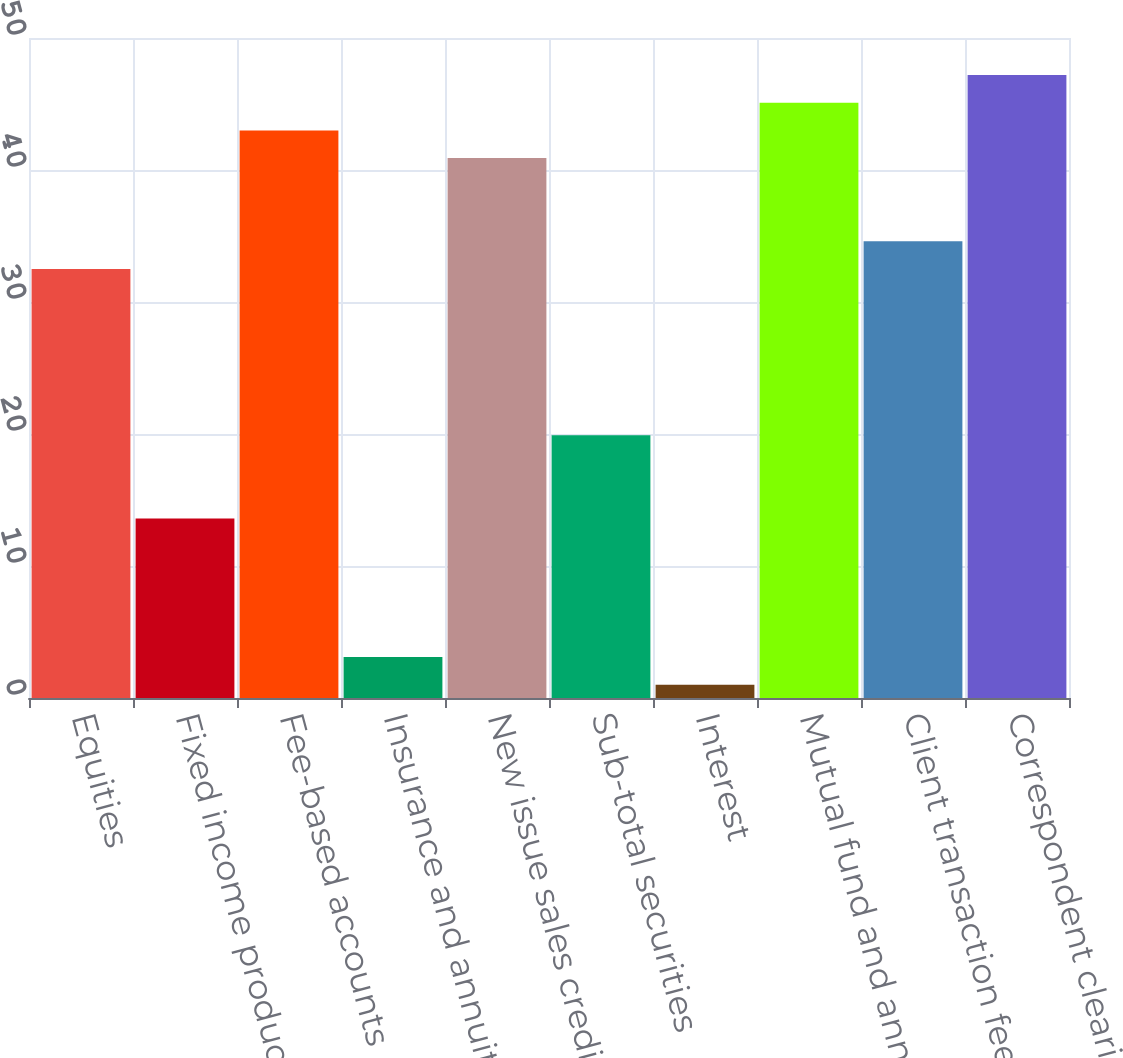Convert chart. <chart><loc_0><loc_0><loc_500><loc_500><bar_chart><fcel>Equities<fcel>Fixed income products<fcel>Fee-based accounts<fcel>Insurance and annuity products<fcel>New issue sales credits<fcel>Sub-total securities<fcel>Interest<fcel>Mutual fund and annuity<fcel>Client transaction fees<fcel>Correspondent clearing fees<nl><fcel>32.5<fcel>13.6<fcel>43<fcel>3.1<fcel>40.9<fcel>19.9<fcel>1<fcel>45.1<fcel>34.6<fcel>47.2<nl></chart> 